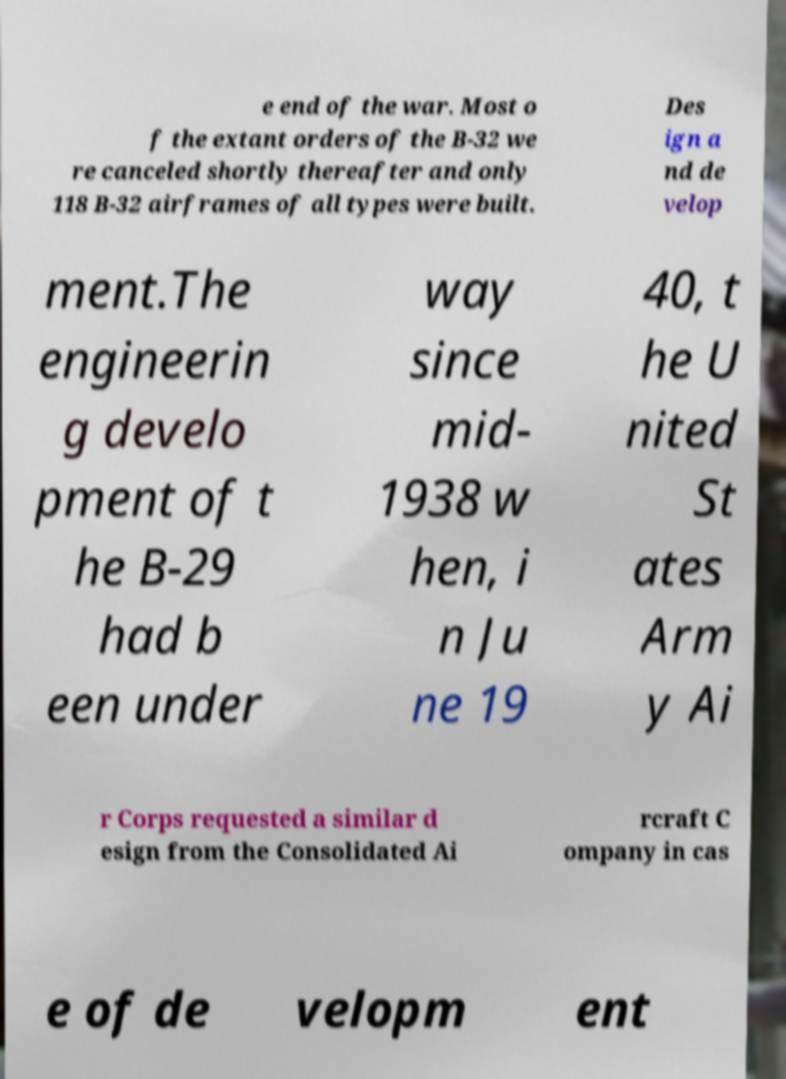Could you extract and type out the text from this image? e end of the war. Most o f the extant orders of the B-32 we re canceled shortly thereafter and only 118 B-32 airframes of all types were built. Des ign a nd de velop ment.The engineerin g develo pment of t he B-29 had b een under way since mid- 1938 w hen, i n Ju ne 19 40, t he U nited St ates Arm y Ai r Corps requested a similar d esign from the Consolidated Ai rcraft C ompany in cas e of de velopm ent 